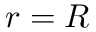<formula> <loc_0><loc_0><loc_500><loc_500>r = R</formula> 